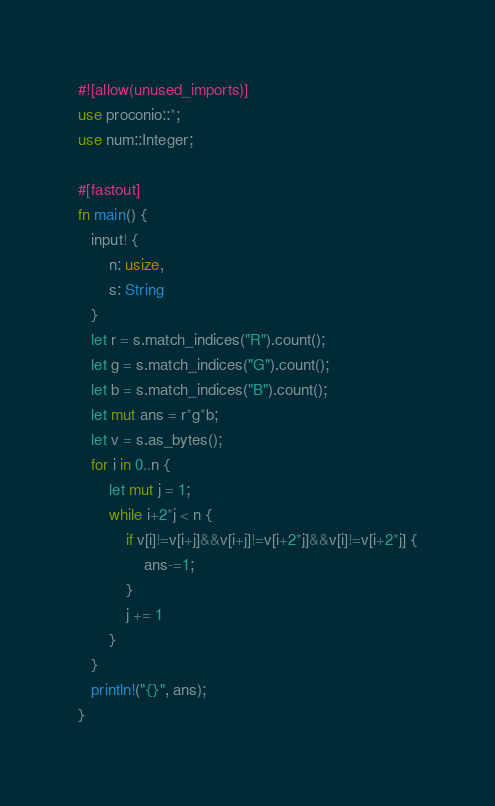Convert code to text. <code><loc_0><loc_0><loc_500><loc_500><_Rust_>#![allow(unused_imports)]
use proconio::*;
use num::Integer;

#[fastout]
fn main() {
   input! {
       n: usize,
       s: String
   }
   let r = s.match_indices("R").count();
   let g = s.match_indices("G").count();
   let b = s.match_indices("B").count();
   let mut ans = r*g*b;
   let v = s.as_bytes();
   for i in 0..n {
       let mut j = 1;
       while i+2*j < n {
           if v[i]!=v[i+j]&&v[i+j]!=v[i+2*j]&&v[i]!=v[i+2*j] {
               ans-=1;
           }
           j += 1
       }
   }
   println!("{}", ans);
}
</code> 